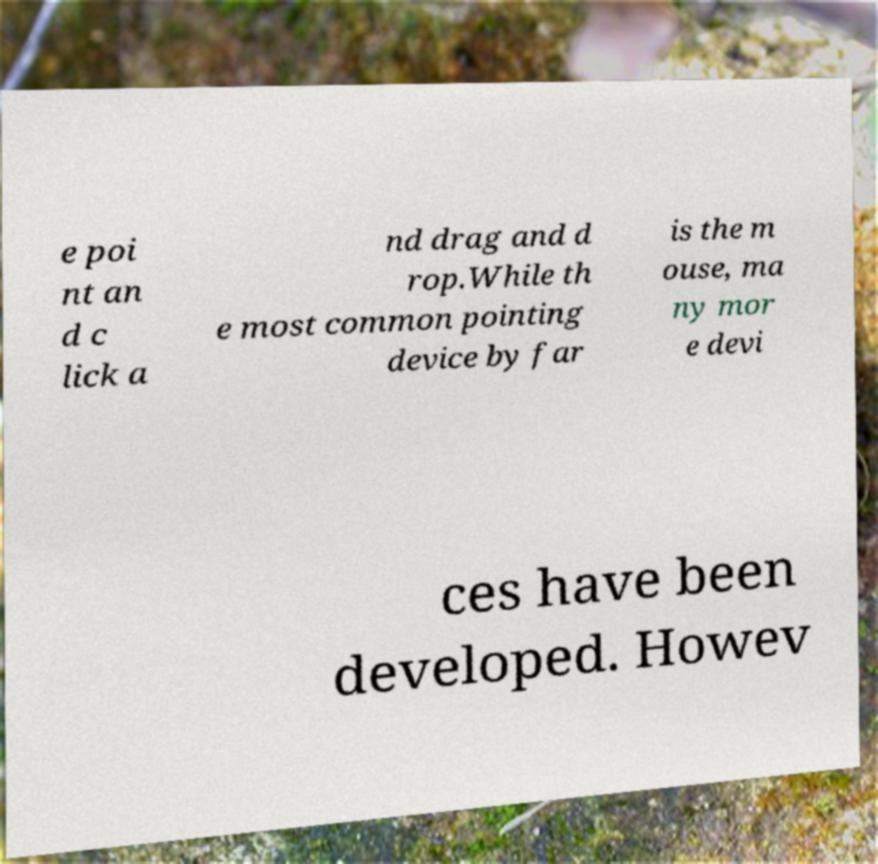Could you assist in decoding the text presented in this image and type it out clearly? e poi nt an d c lick a nd drag and d rop.While th e most common pointing device by far is the m ouse, ma ny mor e devi ces have been developed. Howev 